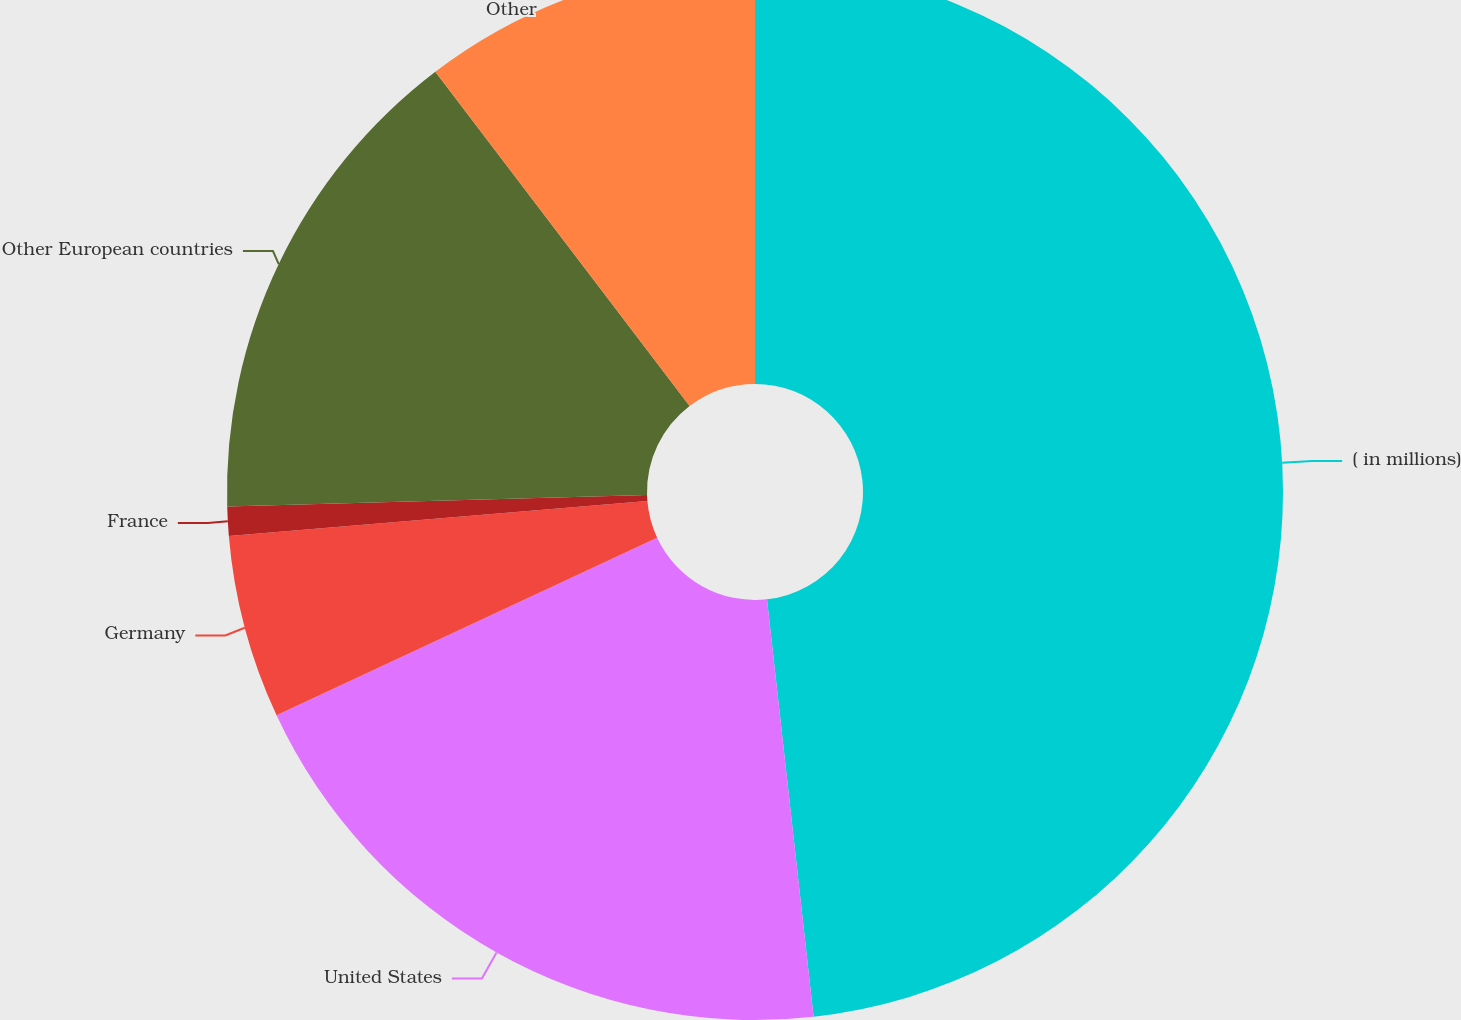<chart> <loc_0><loc_0><loc_500><loc_500><pie_chart><fcel>( in millions)<fcel>United States<fcel>Germany<fcel>France<fcel>Other European countries<fcel>Other<nl><fcel>48.23%<fcel>19.82%<fcel>5.62%<fcel>0.89%<fcel>15.09%<fcel>10.35%<nl></chart> 